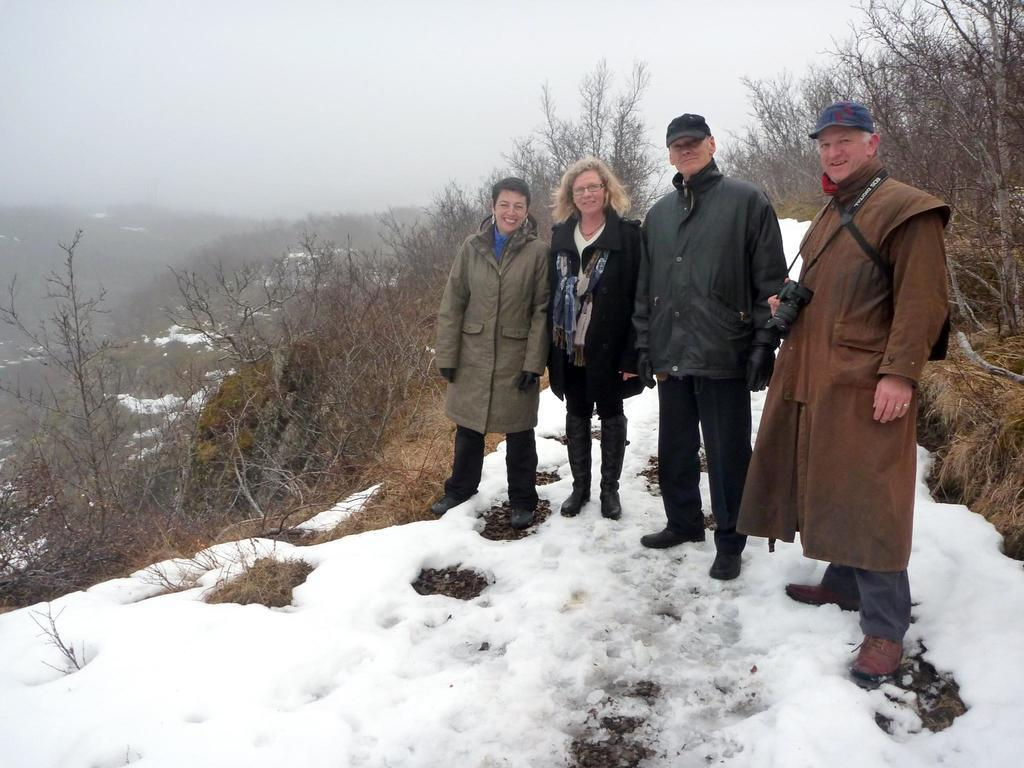Who or what can be seen in the image? There are people in the image. What is the condition of the ground in the image? The ground is covered with snow. What type of vegetation is visible in the image? There are dried grass and plants visible in the image. What can be seen in the distance in the image? There are hills in the background of the image. What part of the natural environment is visible in the image? The sky is visible in the image. What type of verse can be heard being recited by the people in the image? There is no indication in the image that the people are reciting any verse, so it cannot be determined from the picture. 